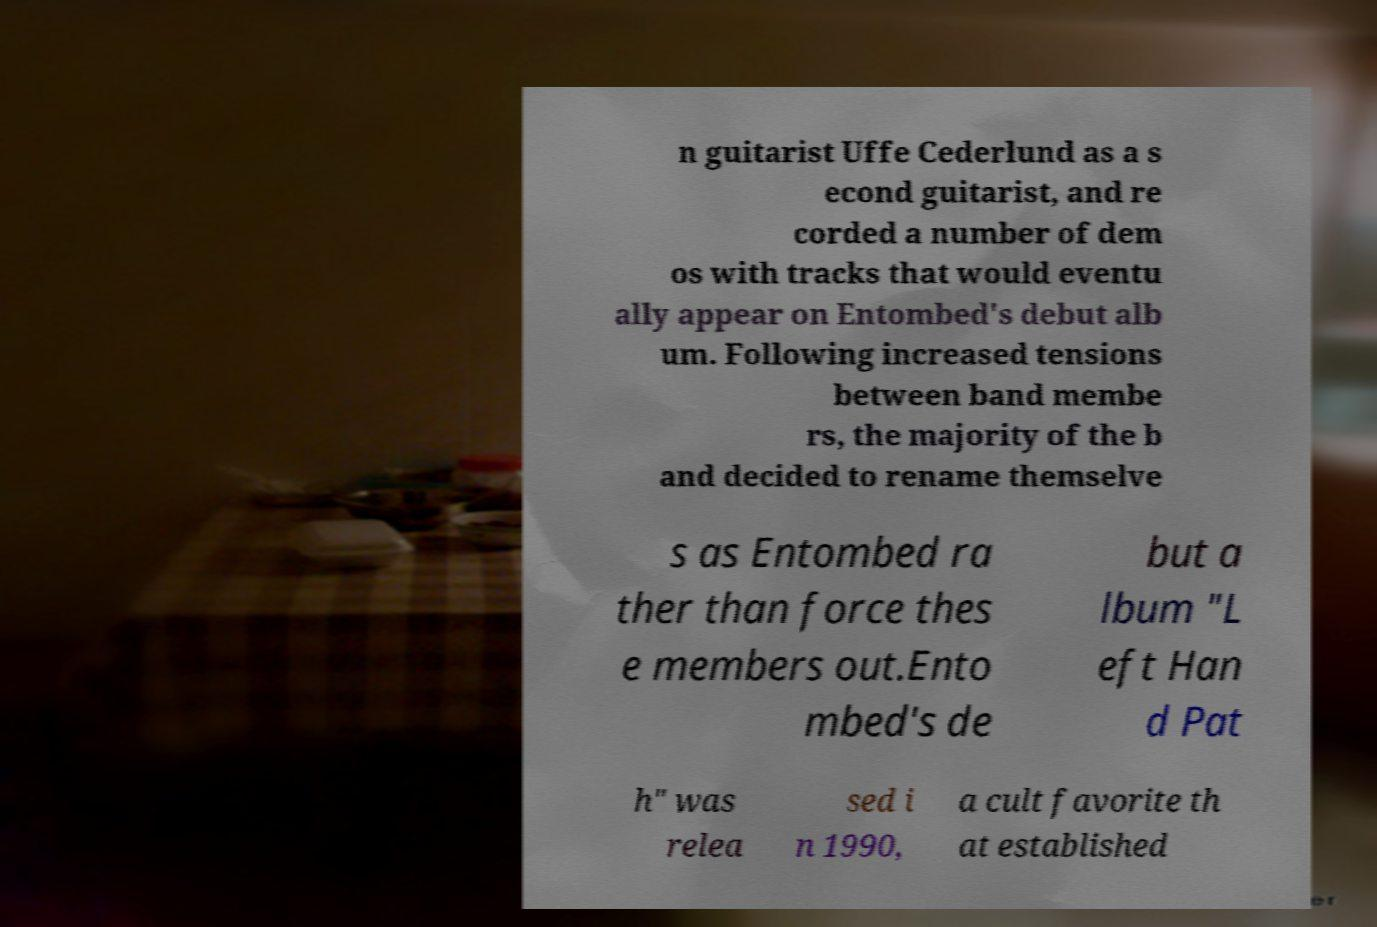Please identify and transcribe the text found in this image. n guitarist Uffe Cederlund as a s econd guitarist, and re corded a number of dem os with tracks that would eventu ally appear on Entombed's debut alb um. Following increased tensions between band membe rs, the majority of the b and decided to rename themselve s as Entombed ra ther than force thes e members out.Ento mbed's de but a lbum "L eft Han d Pat h" was relea sed i n 1990, a cult favorite th at established 